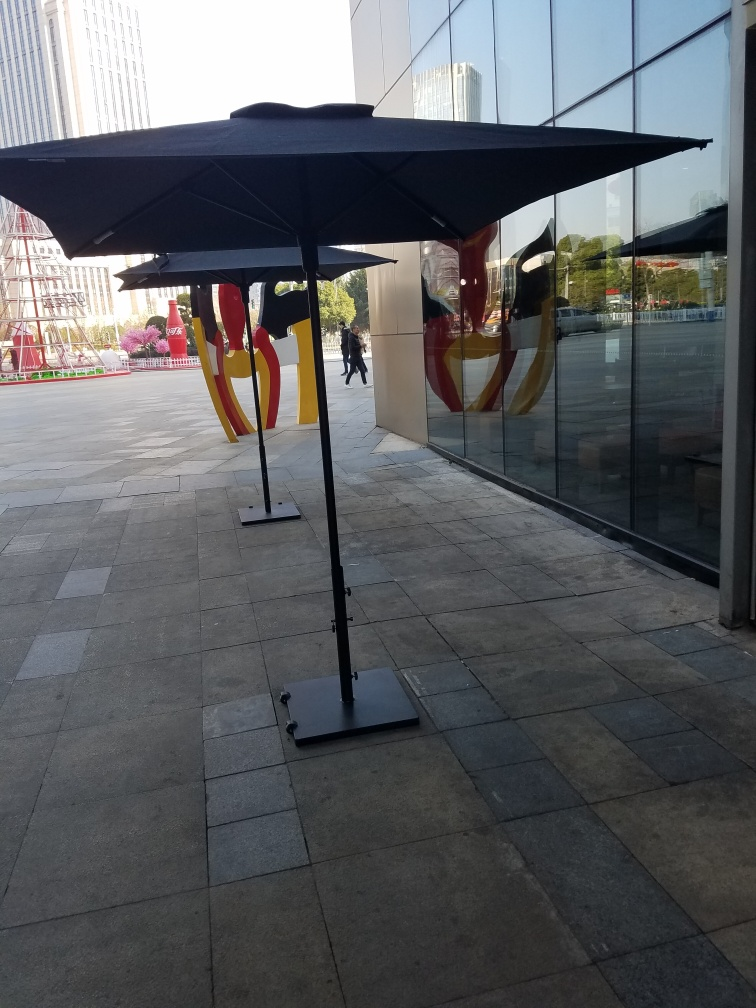Are the colors rich in the image? Yes, the colors in the image are indeed rich. The strong contrast between the bright, vivid reflections on the glass and the deep shadows cast by the umbrellas creates a visually striking scene. The golden and red hues reflected add a warmth that enhances the richness of the image's palette. 